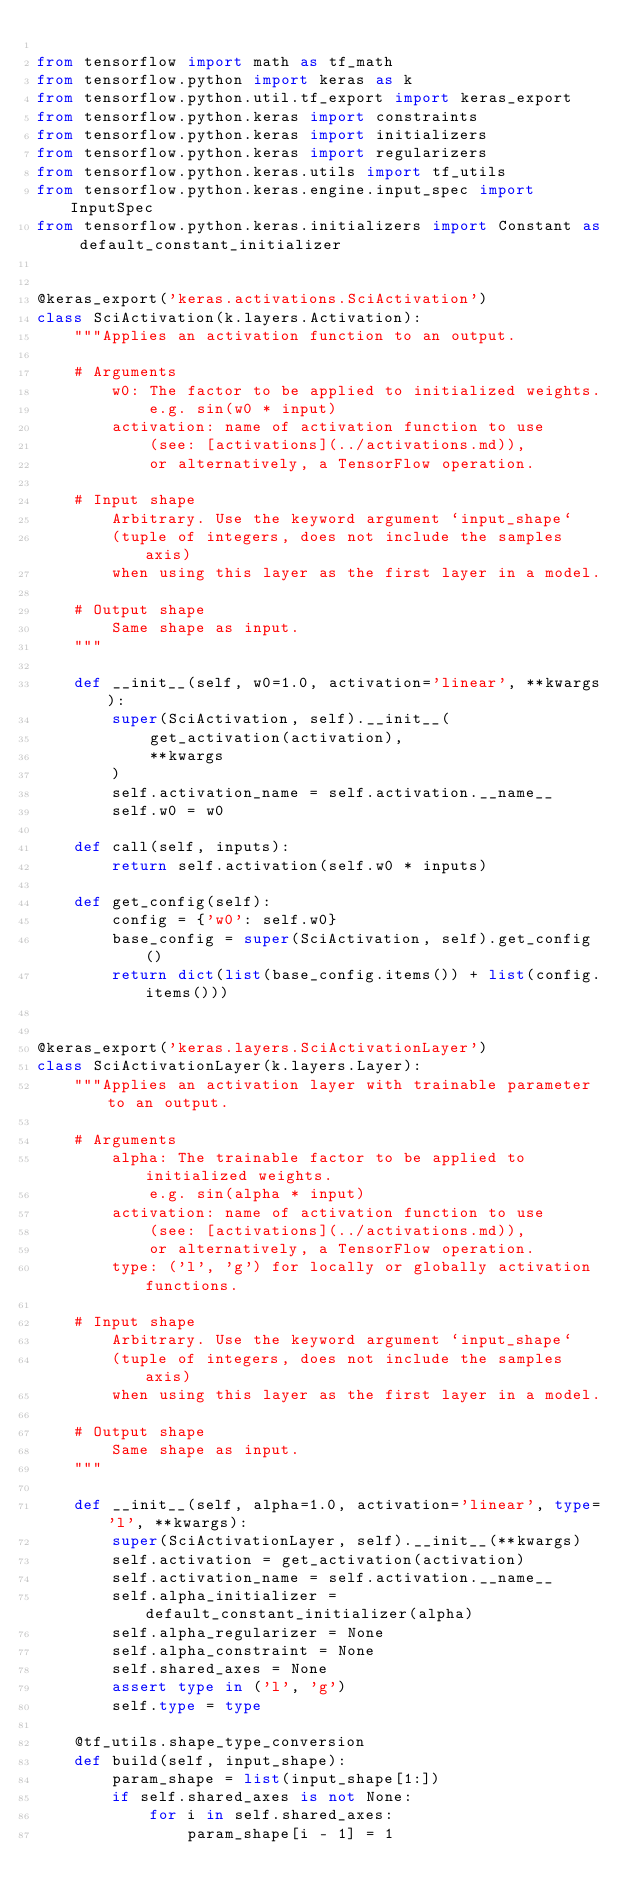<code> <loc_0><loc_0><loc_500><loc_500><_Python_>
from tensorflow import math as tf_math
from tensorflow.python import keras as k
from tensorflow.python.util.tf_export import keras_export
from tensorflow.python.keras import constraints
from tensorflow.python.keras import initializers
from tensorflow.python.keras import regularizers
from tensorflow.python.keras.utils import tf_utils
from tensorflow.python.keras.engine.input_spec import InputSpec
from tensorflow.python.keras.initializers import Constant as default_constant_initializer


@keras_export('keras.activations.SciActivation')
class SciActivation(k.layers.Activation):
    """Applies an activation function to an output.

    # Arguments
        w0: The factor to be applied to initialized weights.
            e.g. sin(w0 * input)
        activation: name of activation function to use
            (see: [activations](../activations.md)),
            or alternatively, a TensorFlow operation.

    # Input shape
        Arbitrary. Use the keyword argument `input_shape`
        (tuple of integers, does not include the samples axis)
        when using this layer as the first layer in a model.

    # Output shape
        Same shape as input.
    """

    def __init__(self, w0=1.0, activation='linear', **kwargs):
        super(SciActivation, self).__init__(
            get_activation(activation),
            **kwargs
        )
        self.activation_name = self.activation.__name__
        self.w0 = w0

    def call(self, inputs):
        return self.activation(self.w0 * inputs)

    def get_config(self):
        config = {'w0': self.w0}
        base_config = super(SciActivation, self).get_config()
        return dict(list(base_config.items()) + list(config.items()))


@keras_export('keras.layers.SciActivationLayer')
class SciActivationLayer(k.layers.Layer):
    """Applies an activation layer with trainable parameter to an output.

    # Arguments
        alpha: The trainable factor to be applied to initialized weights.
            e.g. sin(alpha * input)
        activation: name of activation function to use
            (see: [activations](../activations.md)),
            or alternatively, a TensorFlow operation.
        type: ('l', 'g') for locally or globally activation functions.

    # Input shape
        Arbitrary. Use the keyword argument `input_shape`
        (tuple of integers, does not include the samples axis)
        when using this layer as the first layer in a model.

    # Output shape
        Same shape as input.
    """

    def __init__(self, alpha=1.0, activation='linear', type='l', **kwargs):
        super(SciActivationLayer, self).__init__(**kwargs)
        self.activation = get_activation(activation)
        self.activation_name = self.activation.__name__
        self.alpha_initializer = default_constant_initializer(alpha)
        self.alpha_regularizer = None
        self.alpha_constraint = None
        self.shared_axes = None
        assert type in ('l', 'g')
        self.type = type

    @tf_utils.shape_type_conversion
    def build(self, input_shape):
        param_shape = list(input_shape[1:])
        if self.shared_axes is not None:
            for i in self.shared_axes:
                param_shape[i - 1] = 1</code> 